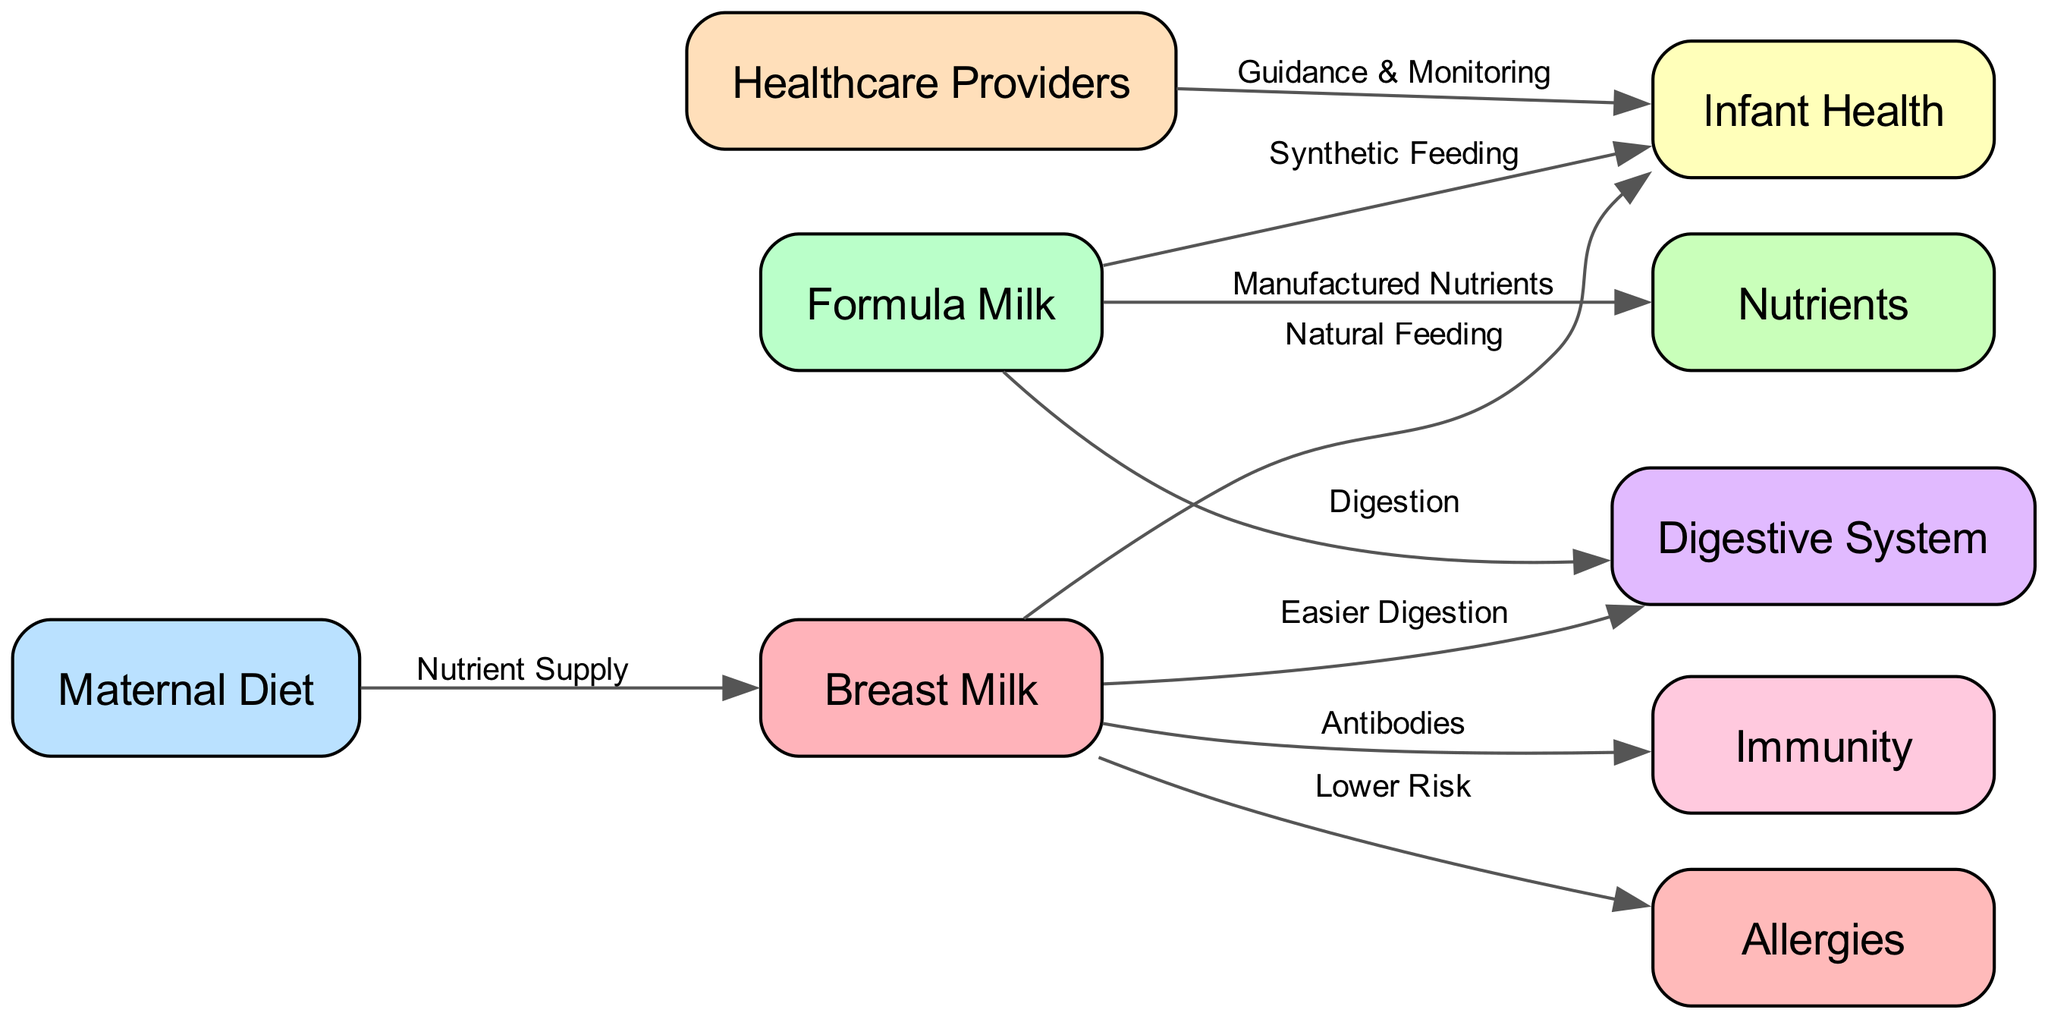What are the two main types of milk shown in the diagram? The diagram displays two main types of milk: "Breast Milk" and "Formula Milk" as separate nodes, explicitly labeled as such.
Answer: Breast Milk, Formula Milk How many nodes are present in the diagram? There are a total of eight distinct nodes representing various aspects of the food chain concerning breastfeeding and formula feeding, which include "Breast Milk," "Formula Milk," "Maternal Diet," "Infant Health," "Immunity," "Digestive System," "Nutrients," "Healthcare Providers," and "Allergies."
Answer: Eight What does "Maternal Diet" supply to "Breast Milk"? The diagram indicates that "Maternal Diet" supplies "Nutrients" to "Breast Milk," establishing a crucial relationship where the quality of the mother's diet directly affects the nutritional value of the milk produced.
Answer: Nutrient Supply Which type of milk is associated with "Antibodies"? The diagram shows that "Breast Milk" is linked to "Immunity" through the transmission of "Antibodies," highlighting one of the key benefits of breastfeeding in providing immune protection to the infant.
Answer: Breast Milk What is the impact of "Formula Milk" on the "Digestive System"? According to the diagram, "Formula Milk" has a connection labeled "Digestion," which implies that it impacts the "Digestive System," but the exact nature of this impact is described differently compared to "Breast Milk."
Answer: Digestion Which node provides "Guidance & Monitoring" related to "Infant Health"? The diagram indicates that "Healthcare Providers" are responsible for "Guidance & Monitoring," suggesting the role of healthcare professionals in advising and overseeing the infant's health during feeding decisions.
Answer: Healthcare Providers What is the relationship between "Breast Milk" and "Allergies"? The diagram establishes a connection labeled "Lower Risk" between "Breast Milk" and "Allergies," suggesting that breastfeeding may reduce the likelihood of allergies in infants compared to formula feeding.
Answer: Lower Risk Which feeding method is labeled as "Synthetic Feeding"? The diagram identifies "Formula Milk" as the method associated with "Synthetic Feeding," distinguishing it from the natural processes involved in breastfeeding.
Answer: Formula Milk 